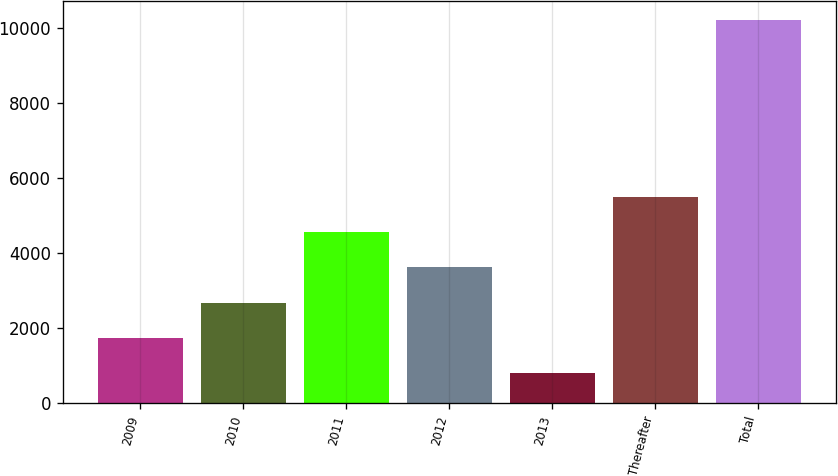Convert chart. <chart><loc_0><loc_0><loc_500><loc_500><bar_chart><fcel>2009<fcel>2010<fcel>2011<fcel>2012<fcel>2013<fcel>Thereafter<fcel>Total<nl><fcel>1736.1<fcel>2679.2<fcel>4565.4<fcel>3622.3<fcel>793<fcel>5508.5<fcel>10224<nl></chart> 